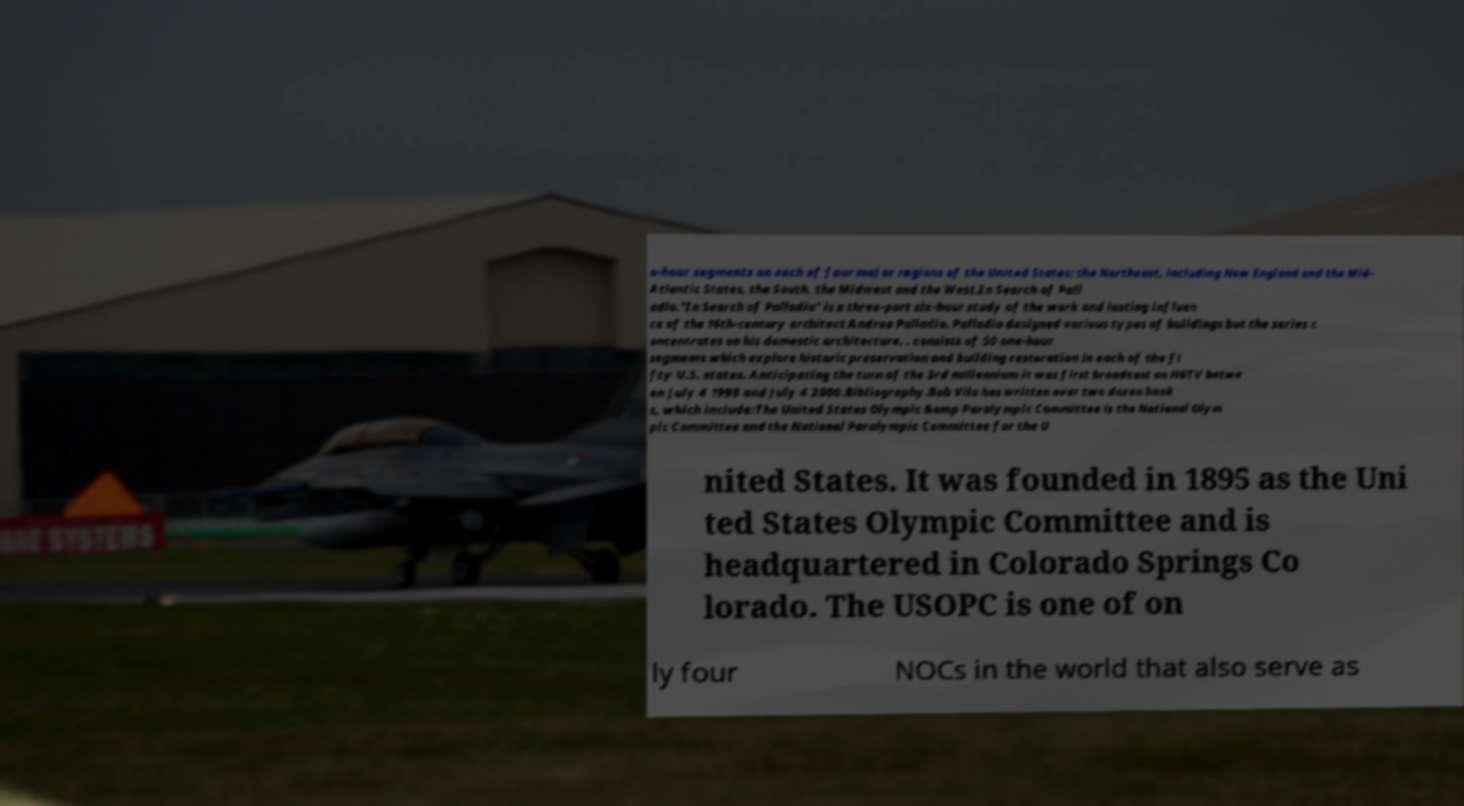Can you read and provide the text displayed in the image?This photo seems to have some interesting text. Can you extract and type it out for me? o-hour segments on each of four major regions of the United States: the Northeast, including New England and the Mid- Atlantic States, the South, the Midwest and the West.In Search of Pall adio."In Search of Palladio" is a three-part six-hour study of the work and lasting influen ce of the 16th-century architect Andrea Palladio. Palladio designed various types of buildings but the series c oncentrates on his domestic architecture. . consists of 50 one-hour segments which explore historic preservation and building restoration in each of the fi fty U.S. states. Anticipating the turn of the 3rd millennium it was first broadcast on HGTV betwe en July 4 1999 and July 4 2000.Bibliography.Bob Vila has written over two dozen book s, which include:The United States Olympic &amp Paralympic Committee is the National Olym pic Committee and the National Paralympic Committee for the U nited States. It was founded in 1895 as the Uni ted States Olympic Committee and is headquartered in Colorado Springs Co lorado. The USOPC is one of on ly four NOCs in the world that also serve as 